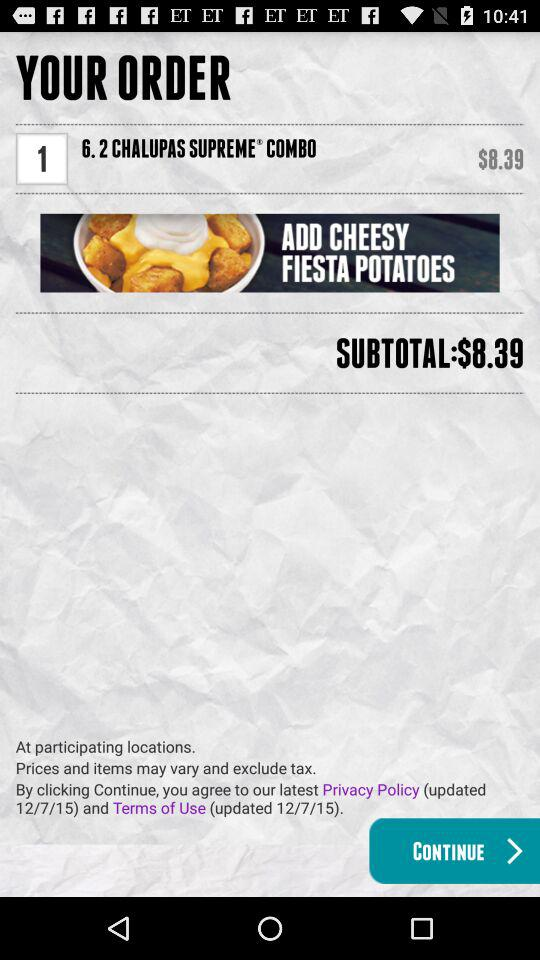What is the order? The order is "6.2 CHALUPAS SUPREME® COMBO". 